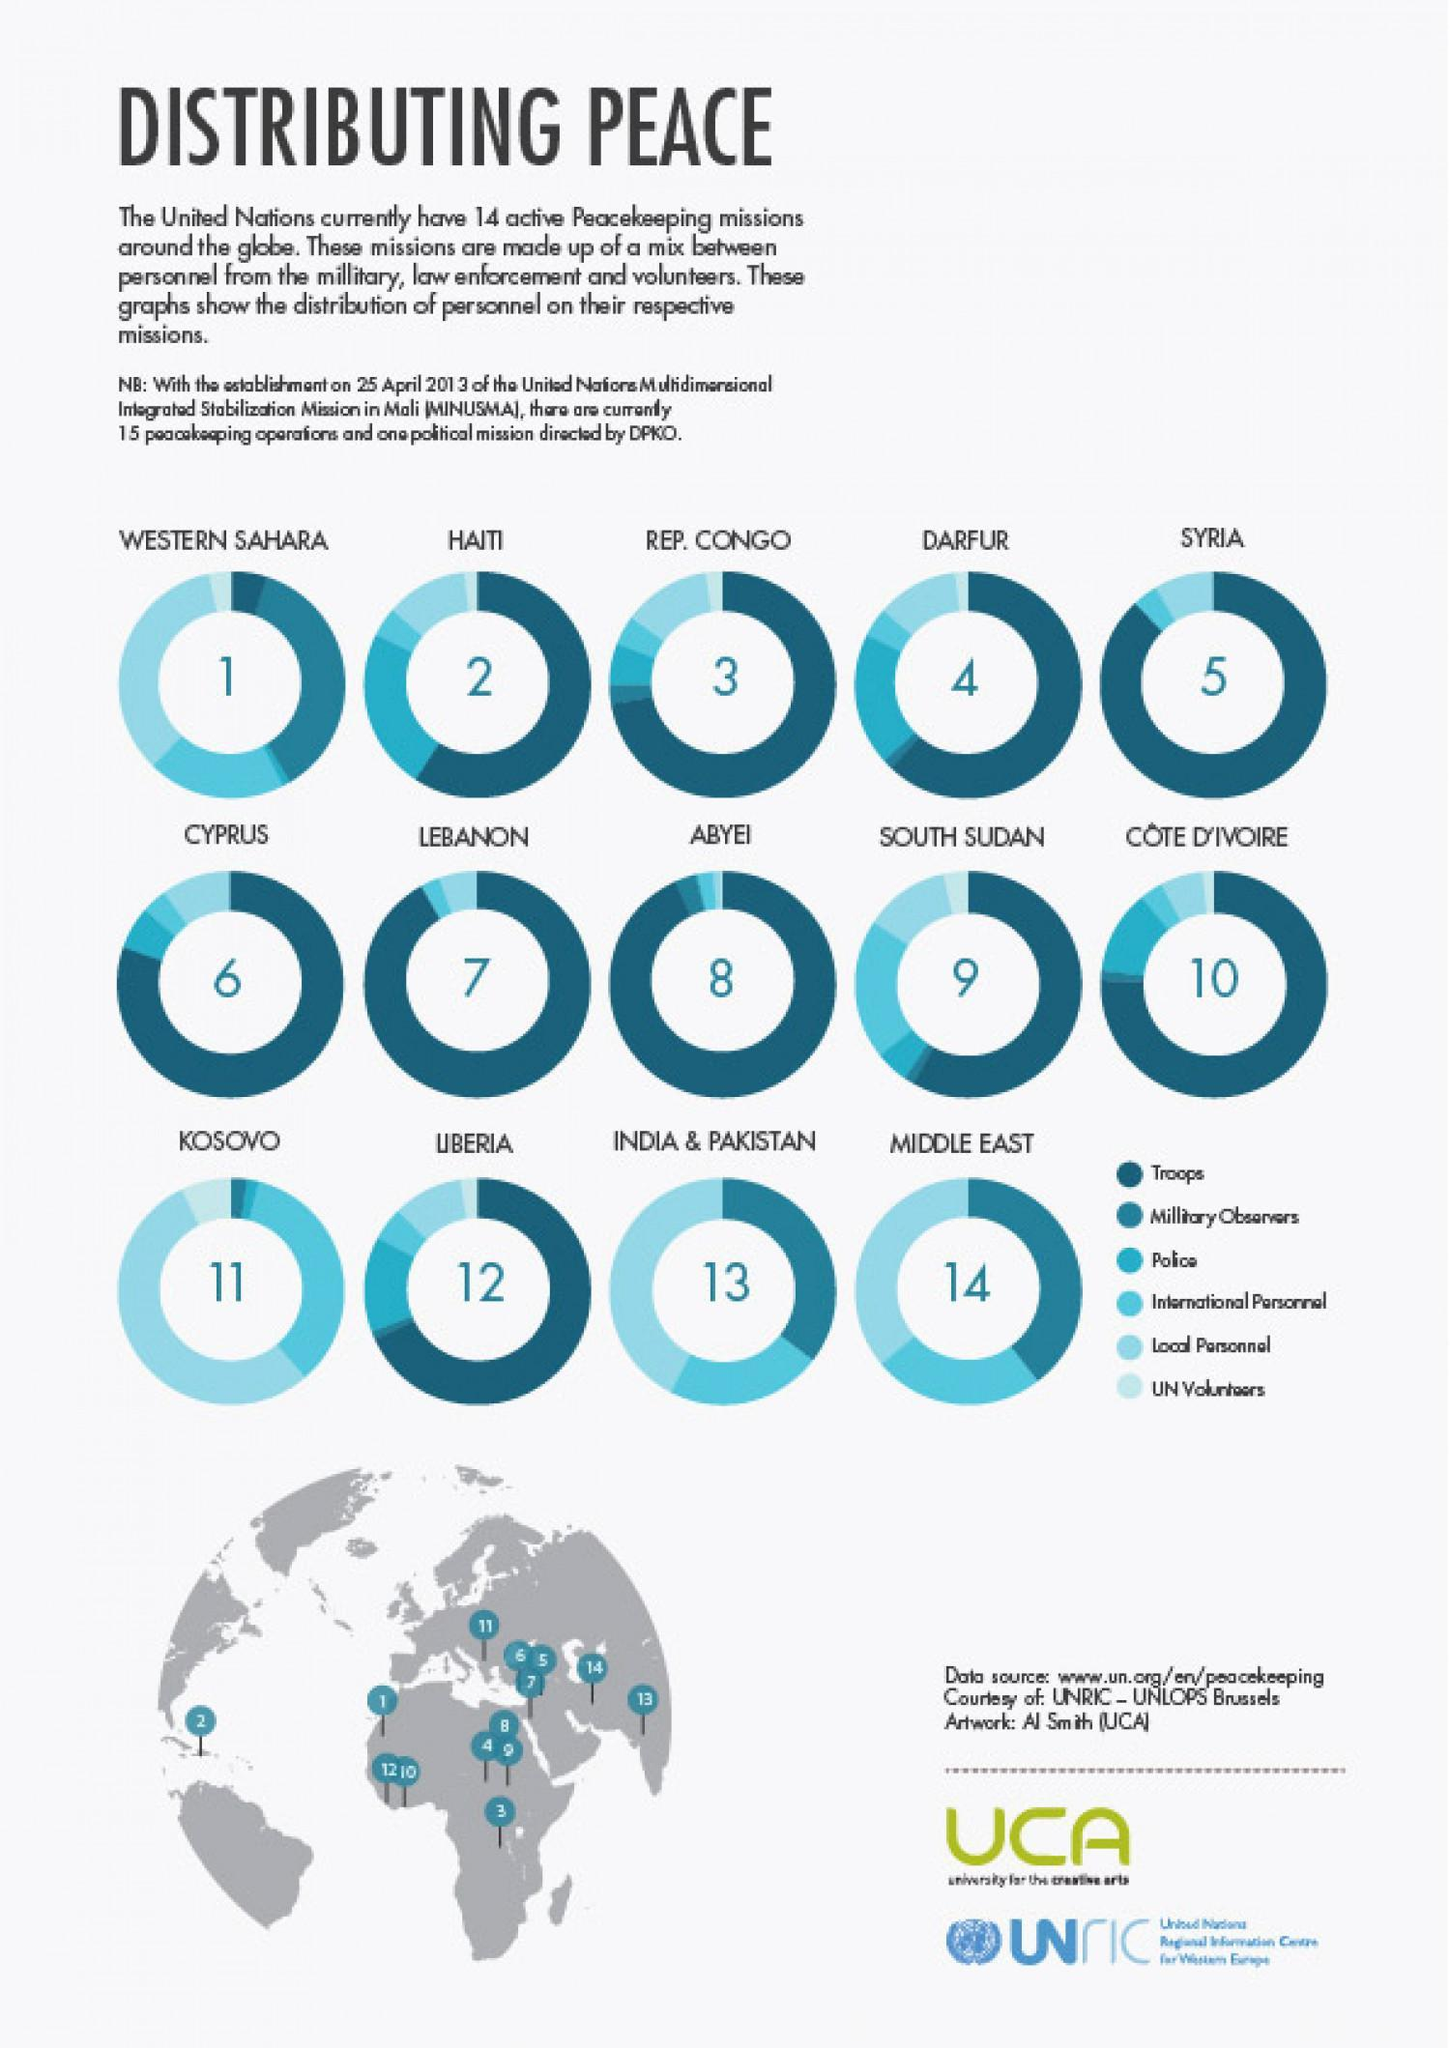The share of troops among peace keeping personnel is highest in which area/country?
Answer the question with a short phrase. Abyei Which are the two asian countries where UN has one common peace keeping mission? india & pakistan In liberia, which category of personnel has the highest share? troops Among the peace missions, mission in which country/area has the share of troops and military observers among the personnel is the least? Kosovo As per the given map, which continent has most number of peace keeping missions of UN - Asia, Europe, Africa or North America? Africa 